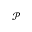<formula> <loc_0><loc_0><loc_500><loc_500>\mathcal { P }</formula> 